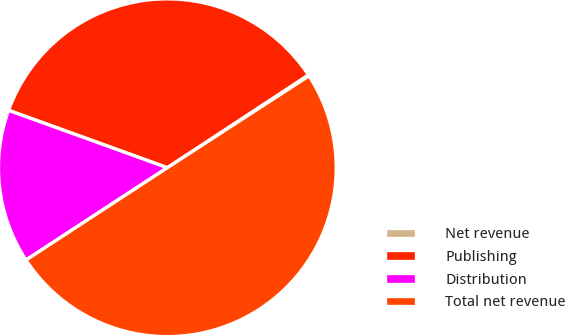<chart> <loc_0><loc_0><loc_500><loc_500><pie_chart><fcel>Net revenue<fcel>Publishing<fcel>Distribution<fcel>Total net revenue<nl><fcel>0.1%<fcel>35.22%<fcel>14.73%<fcel>49.95%<nl></chart> 